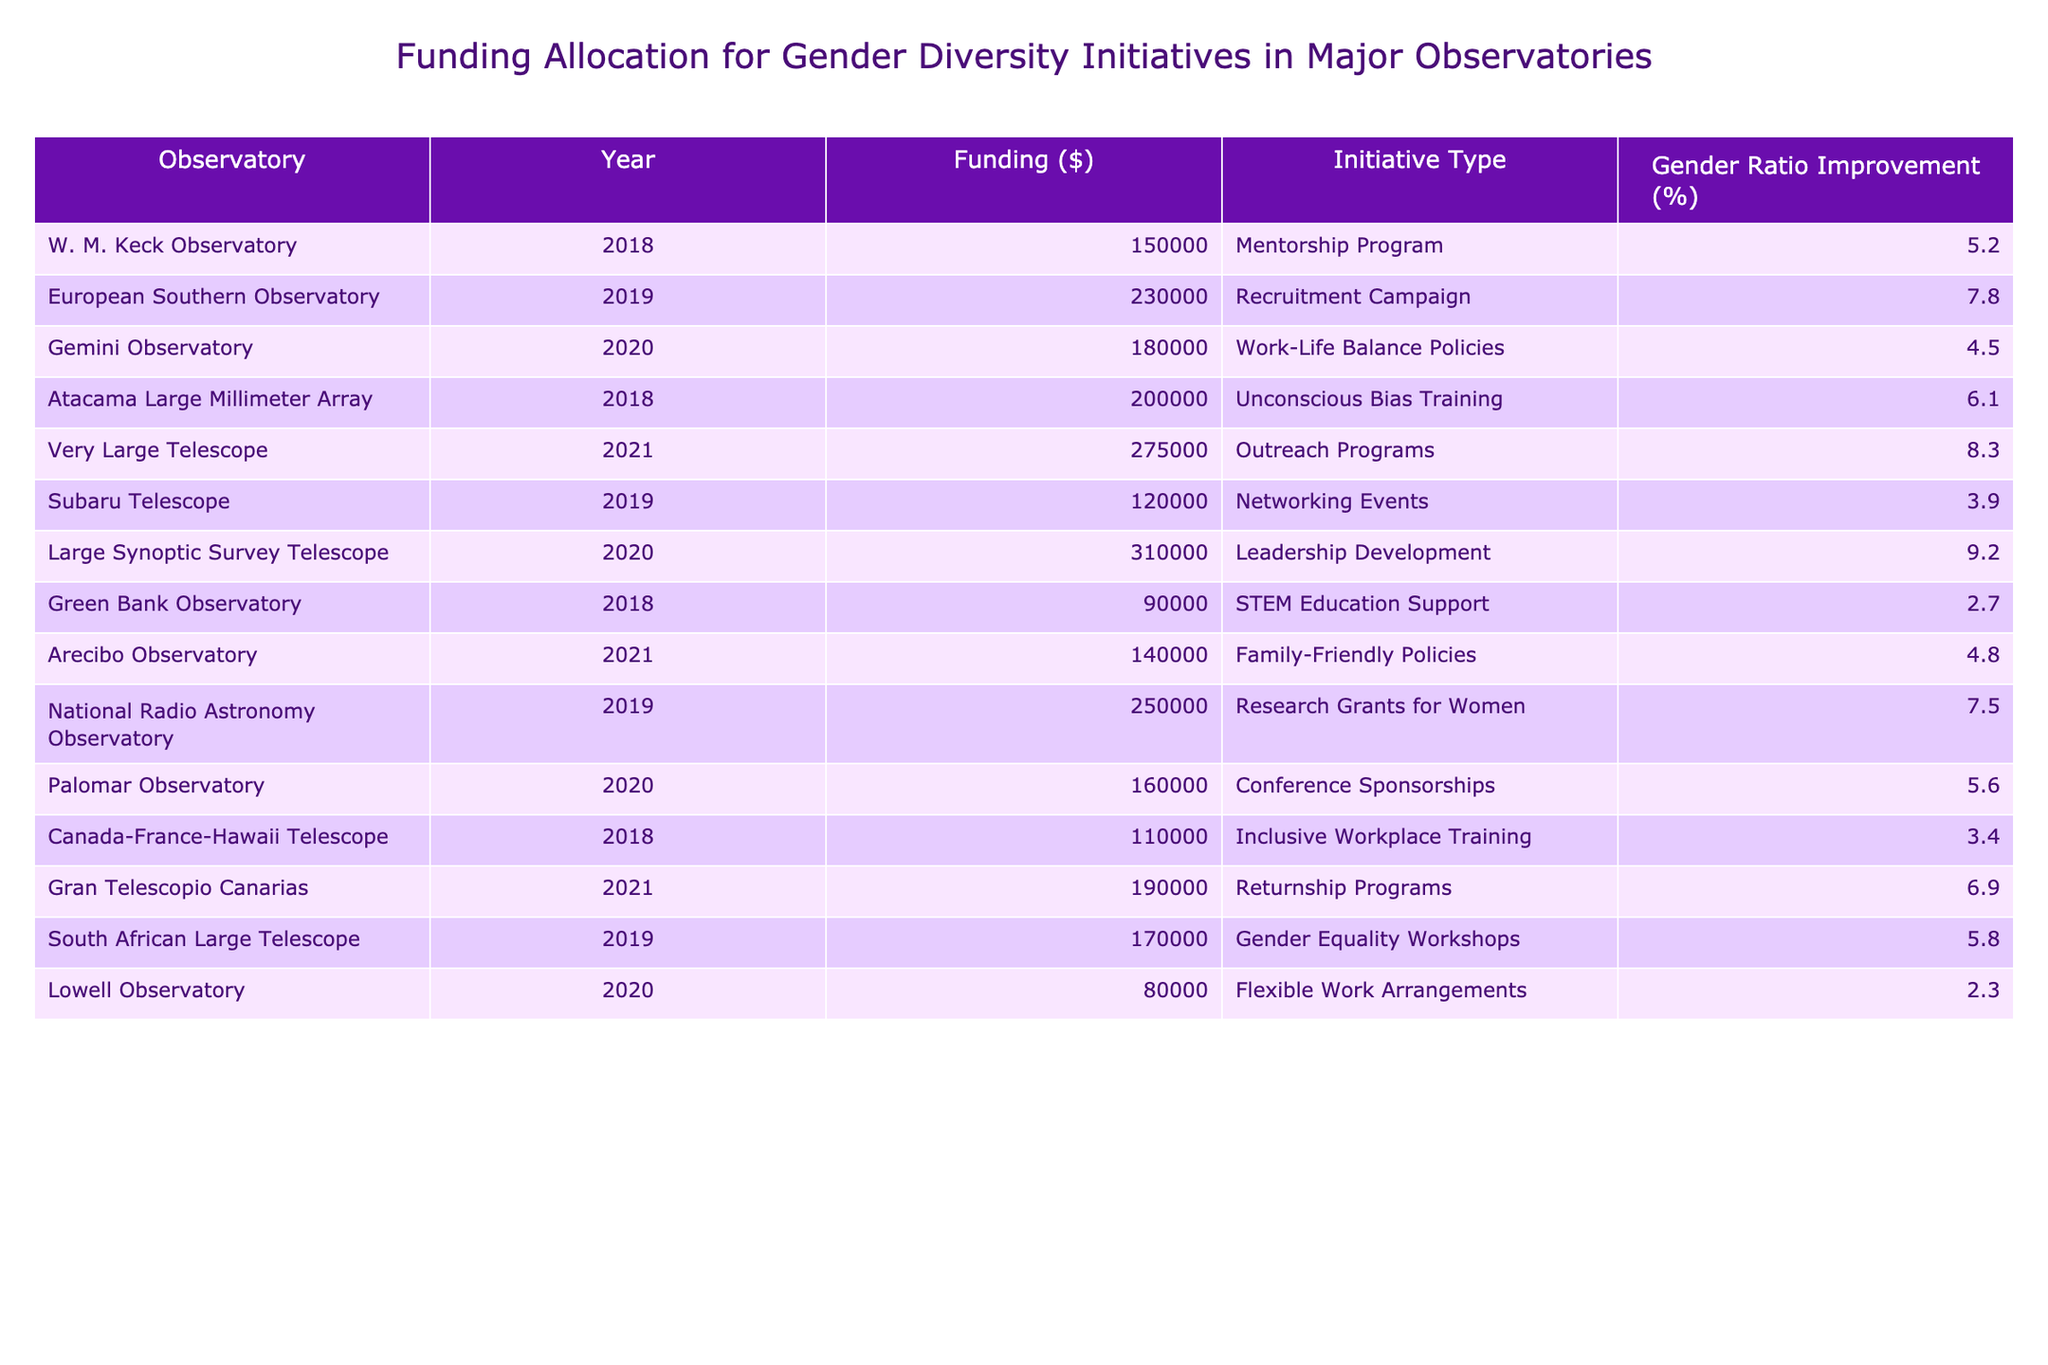What was the largest funding allocation and for which initiative? The largest funding allocation is $310,000, associated with the Leadership Development initiative at the Large Synoptic Survey Telescope.
Answer: $310,000; Leadership Development Which observatory had the lowest funding in 2018? The Green Bank Observatory had the lowest funding in 2018 at $90,000.
Answer: $90,000; Green Bank Observatory What is the average funding across all initiatives for 2021? The total funding for 2021 is $605,000 from three initiatives ($275,000 + $140,000 + $190,000), giving an average of $605,000 / 3 = $201,666.67.
Answer: $201,666.67 Did the Very Large Telescope have a higher funding allocation than the Atacama Large Millimeter Array? Yes, the Very Large Telescope had funding of $275,000, which is greater than the Atacama Large Millimeter Array's funding of $200,000.
Answer: Yes What percentage improvement in gender ratio was achieved through the Outreach Programs? The Outreach Programs resulted in an 8.3% improvement in gender ratio.
Answer: 8.3% Which initiative showed the smallest improvement in gender ratio and what was that improvement? The Flexible Work Arrangements initiative showed the smallest improvement in gender ratio at 2.3%.
Answer: 2.3%; Flexible Work Arrangements How many initiatives had a funding amount greater than $200,000? There are three initiatives with funding greater than $200,000: Leadership Development ($310,000), Very Large Telescope Outreach Programs ($275,000), and Recruitment Campaign ($230,000).
Answer: 3 What was the total funding allocated for women-related research initiatives across all observatories? The total funding for women-related research initiatives, which includes Research Grants for Women and Family-Friendly Policies, is $390,000 ($250,000 + $140,000).
Answer: $390,000 Which two observatories had initiatives providing the highest percentage improvement in gender ratio, and what were those percentages? The two observatories with the highest percentage improvements are the Large Synoptic Survey Telescope with 9.2% and the Very Large Telescope with 8.3%.
Answer: Large Synoptic Survey Telescope; 9.2%; Very Large Telescope; 8.3% If we combine the gender ratio improvements for 2019, what is the total improvement percentage? The total improvement percentage for 2019 can be calculated as follows: European Southern Observatory (7.8%) + National Radio Astronomy Observatory (7.5%) + Subaru Telescope (3.9%) + South African Large Telescope (5.8%) = 25%.
Answer: 25% 